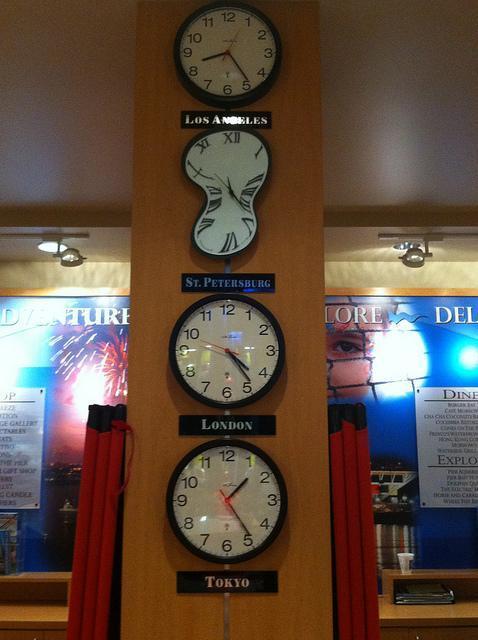How many clocks are there?
Give a very brief answer. 4. 